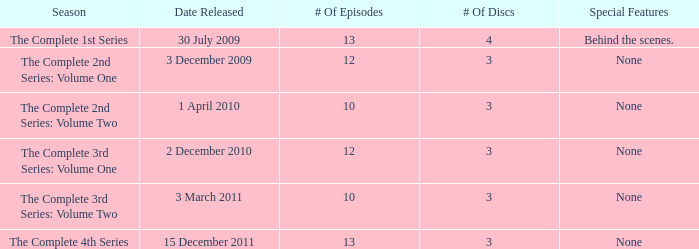How many discs for the entire 4th season? 3.0. 